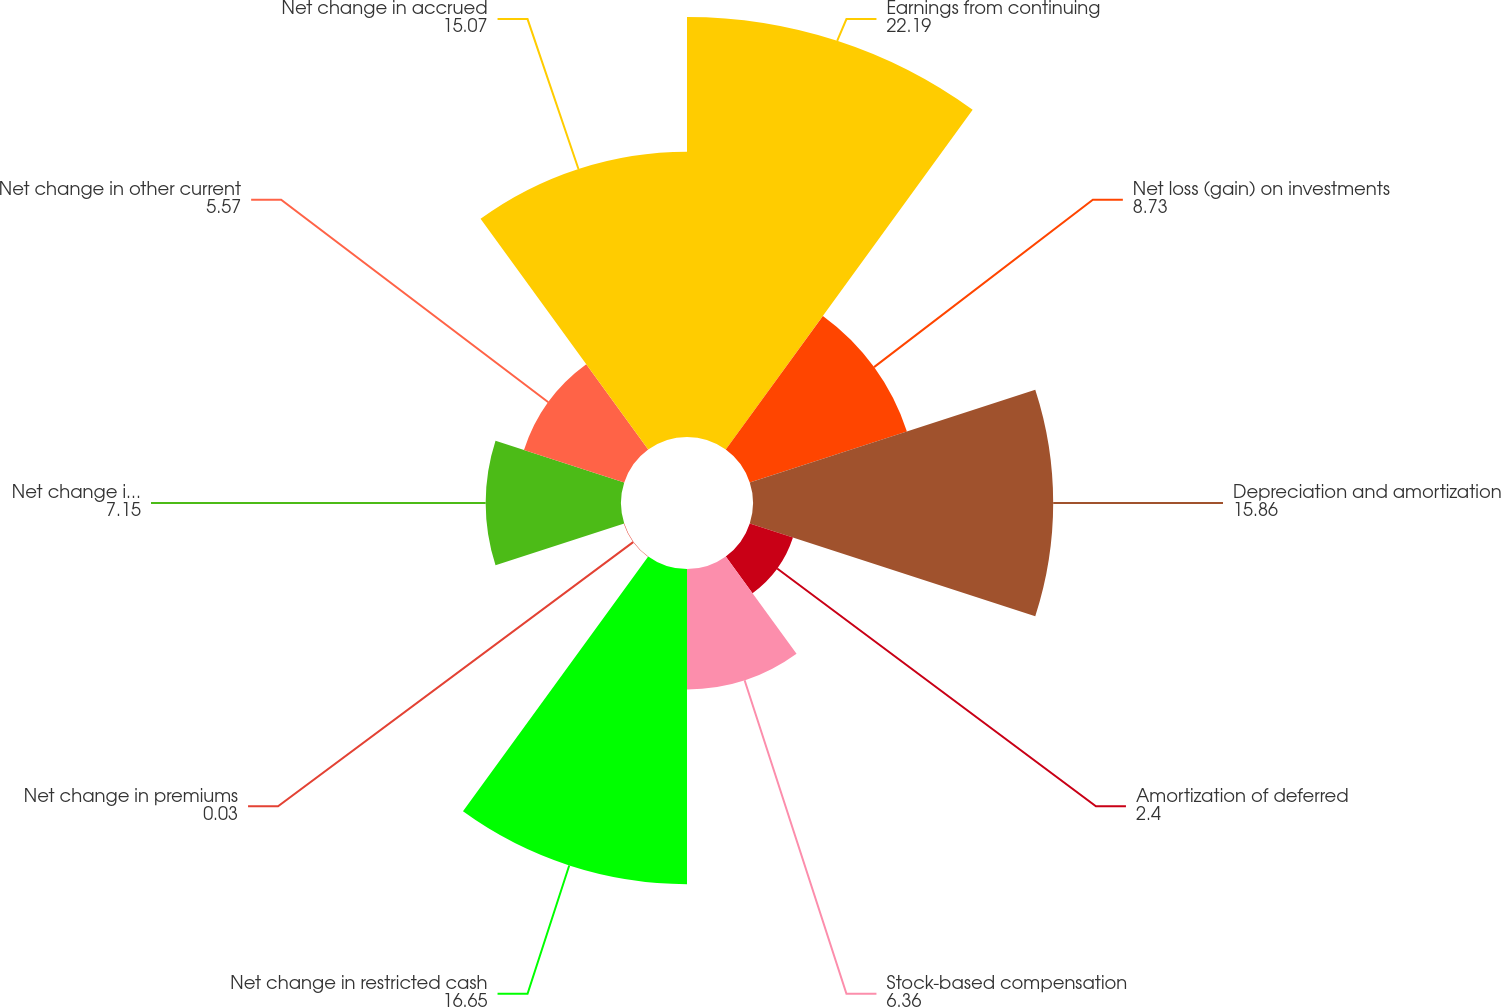<chart> <loc_0><loc_0><loc_500><loc_500><pie_chart><fcel>Earnings from continuing<fcel>Net loss (gain) on investments<fcel>Depreciation and amortization<fcel>Amortization of deferred<fcel>Stock-based compensation<fcel>Net change in restricted cash<fcel>Net change in premiums<fcel>Net change in premiums payable<fcel>Net change in other current<fcel>Net change in accrued<nl><fcel>22.19%<fcel>8.73%<fcel>15.86%<fcel>2.4%<fcel>6.36%<fcel>16.65%<fcel>0.03%<fcel>7.15%<fcel>5.57%<fcel>15.07%<nl></chart> 